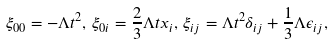<formula> <loc_0><loc_0><loc_500><loc_500>\xi _ { 0 0 } = - \Lambda t ^ { 2 } , \, \xi _ { 0 i } = \frac { 2 } { 3 } \Lambda t x _ { i } , \, \xi _ { i j } = \Lambda t ^ { 2 } \delta _ { i j } + \frac { 1 } { 3 } \Lambda \epsilon _ { i j } ,</formula> 